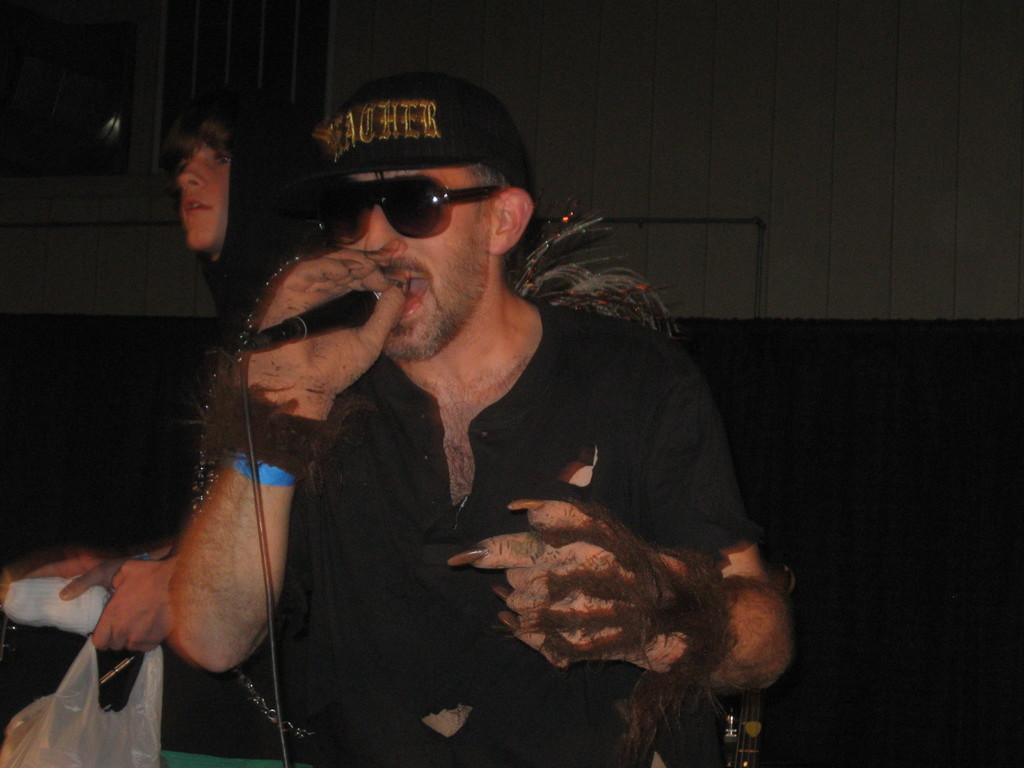Can you describe this image briefly? In this picture we can see a man holding mic with his hand and talking and at back of him we can see other person holding plastic cover and a cloth with his hand and in the background we can see wall. 